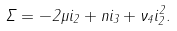<formula> <loc_0><loc_0><loc_500><loc_500>\Sigma = - 2 \mu i _ { 2 } + n i _ { 3 } + \nu _ { 4 } i _ { 2 } ^ { 2 } .</formula> 